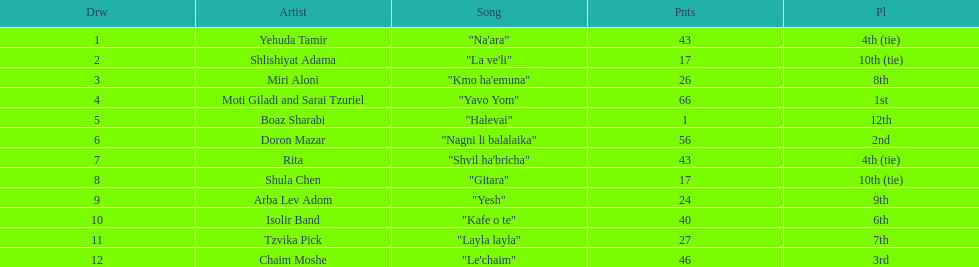What is the aggregate number of ties in this event? 2. 